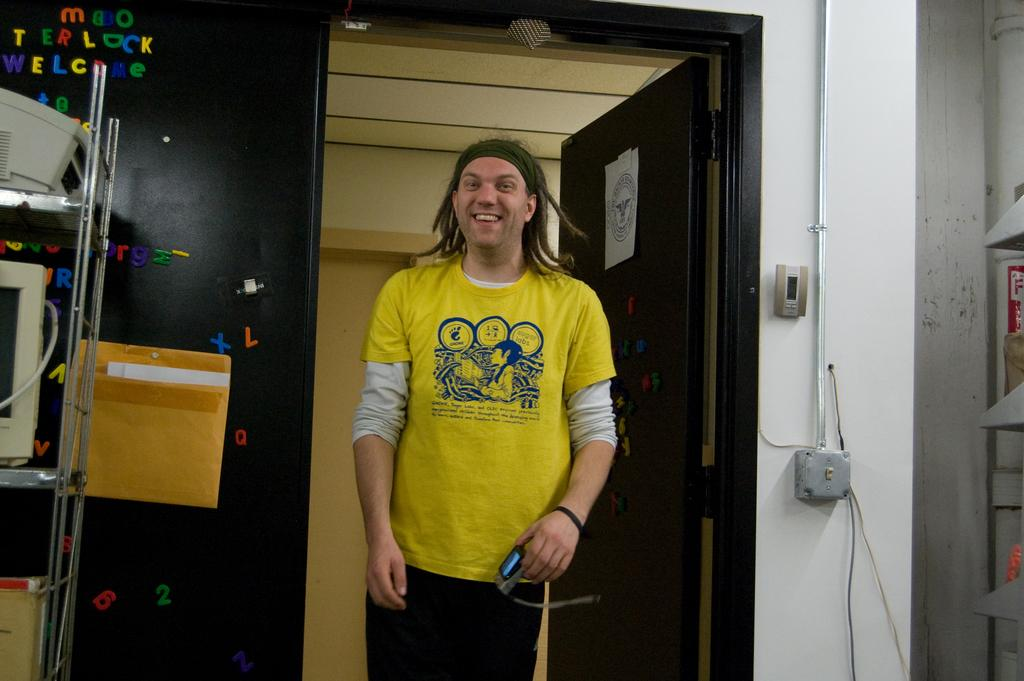What type of structure can be seen in the image? There is a wall in the image. Is there any entrance visible in the image? Yes, there is a door in the image. Can you describe the person in the image? There is a person wearing a yellow t-shirt in the image. What is the purpose of the rack in the image? The purpose of the rack is not specified, but it could be used for storage or display. What is the screen used for in the image? The purpose of the screen is not specified, but it could be used for displaying information or as a monitor. What type of objects can be seen on the floor in the image? There are boxes in the image. What type of thought can be seen floating above the person's head in the image? There is no thought visible in the image; it only shows a person wearing a yellow t-shirt. What type of copper material is present in the image? There is no copper material present in the image. Is there a cactus visible in the image? There is no cactus present in the image. 